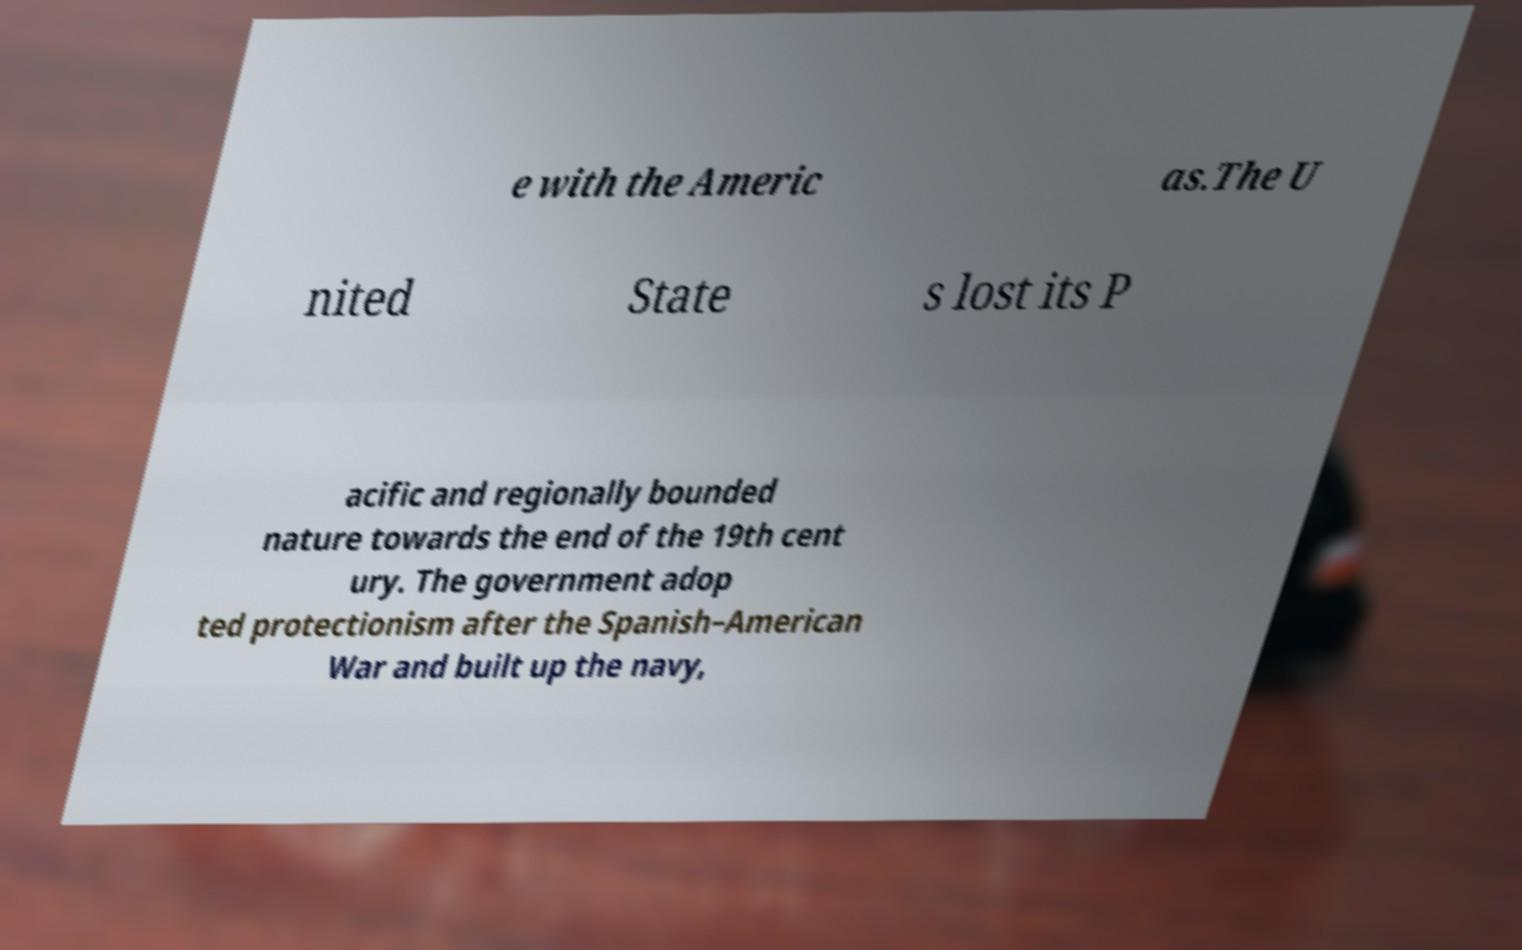What messages or text are displayed in this image? I need them in a readable, typed format. e with the Americ as.The U nited State s lost its P acific and regionally bounded nature towards the end of the 19th cent ury. The government adop ted protectionism after the Spanish–American War and built up the navy, 